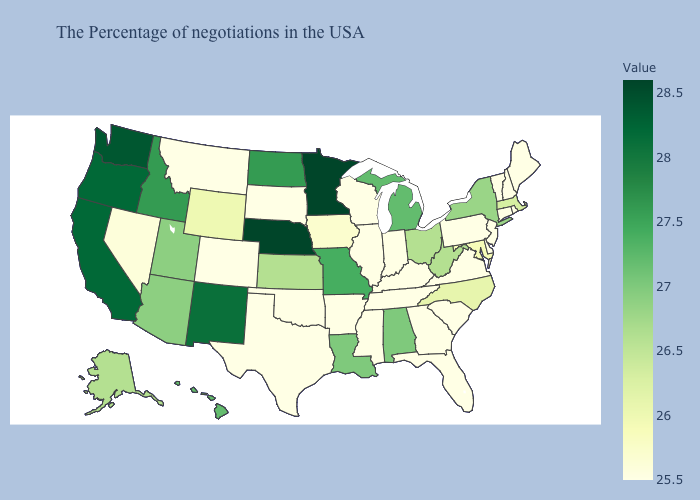Among the states that border Kansas , does Nebraska have the highest value?
Quick response, please. Yes. Which states have the lowest value in the USA?
Short answer required. Maine, Rhode Island, New Hampshire, Vermont, Connecticut, New Jersey, Delaware, Pennsylvania, Virginia, South Carolina, Florida, Georgia, Kentucky, Indiana, Tennessee, Wisconsin, Illinois, Mississippi, Arkansas, Oklahoma, Texas, South Dakota, Colorado, Montana. Does New York have the highest value in the Northeast?
Give a very brief answer. Yes. 